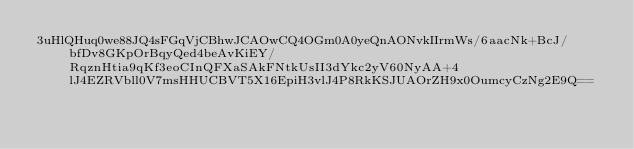Convert code to text. <code><loc_0><loc_0><loc_500><loc_500><_SML_>3uHlQHuq0we88JQ4sFGqVjCBhwJCAOwCQ4OGm0A0yeQnAONvkIIrmWs/6aacNk+BcJ/bfDv8GKpOrBqyQed4beAvKiEY/RqznHtia9qKf3eoCInQFXaSAkFNtkUsII3dYkc2yV60NyAA+4lJ4EZRVbll0V7msHHUCBVT5X16EpiH3vlJ4P8RkKSJUAOrZH9x0OumcyCzNg2E9Q==</code> 